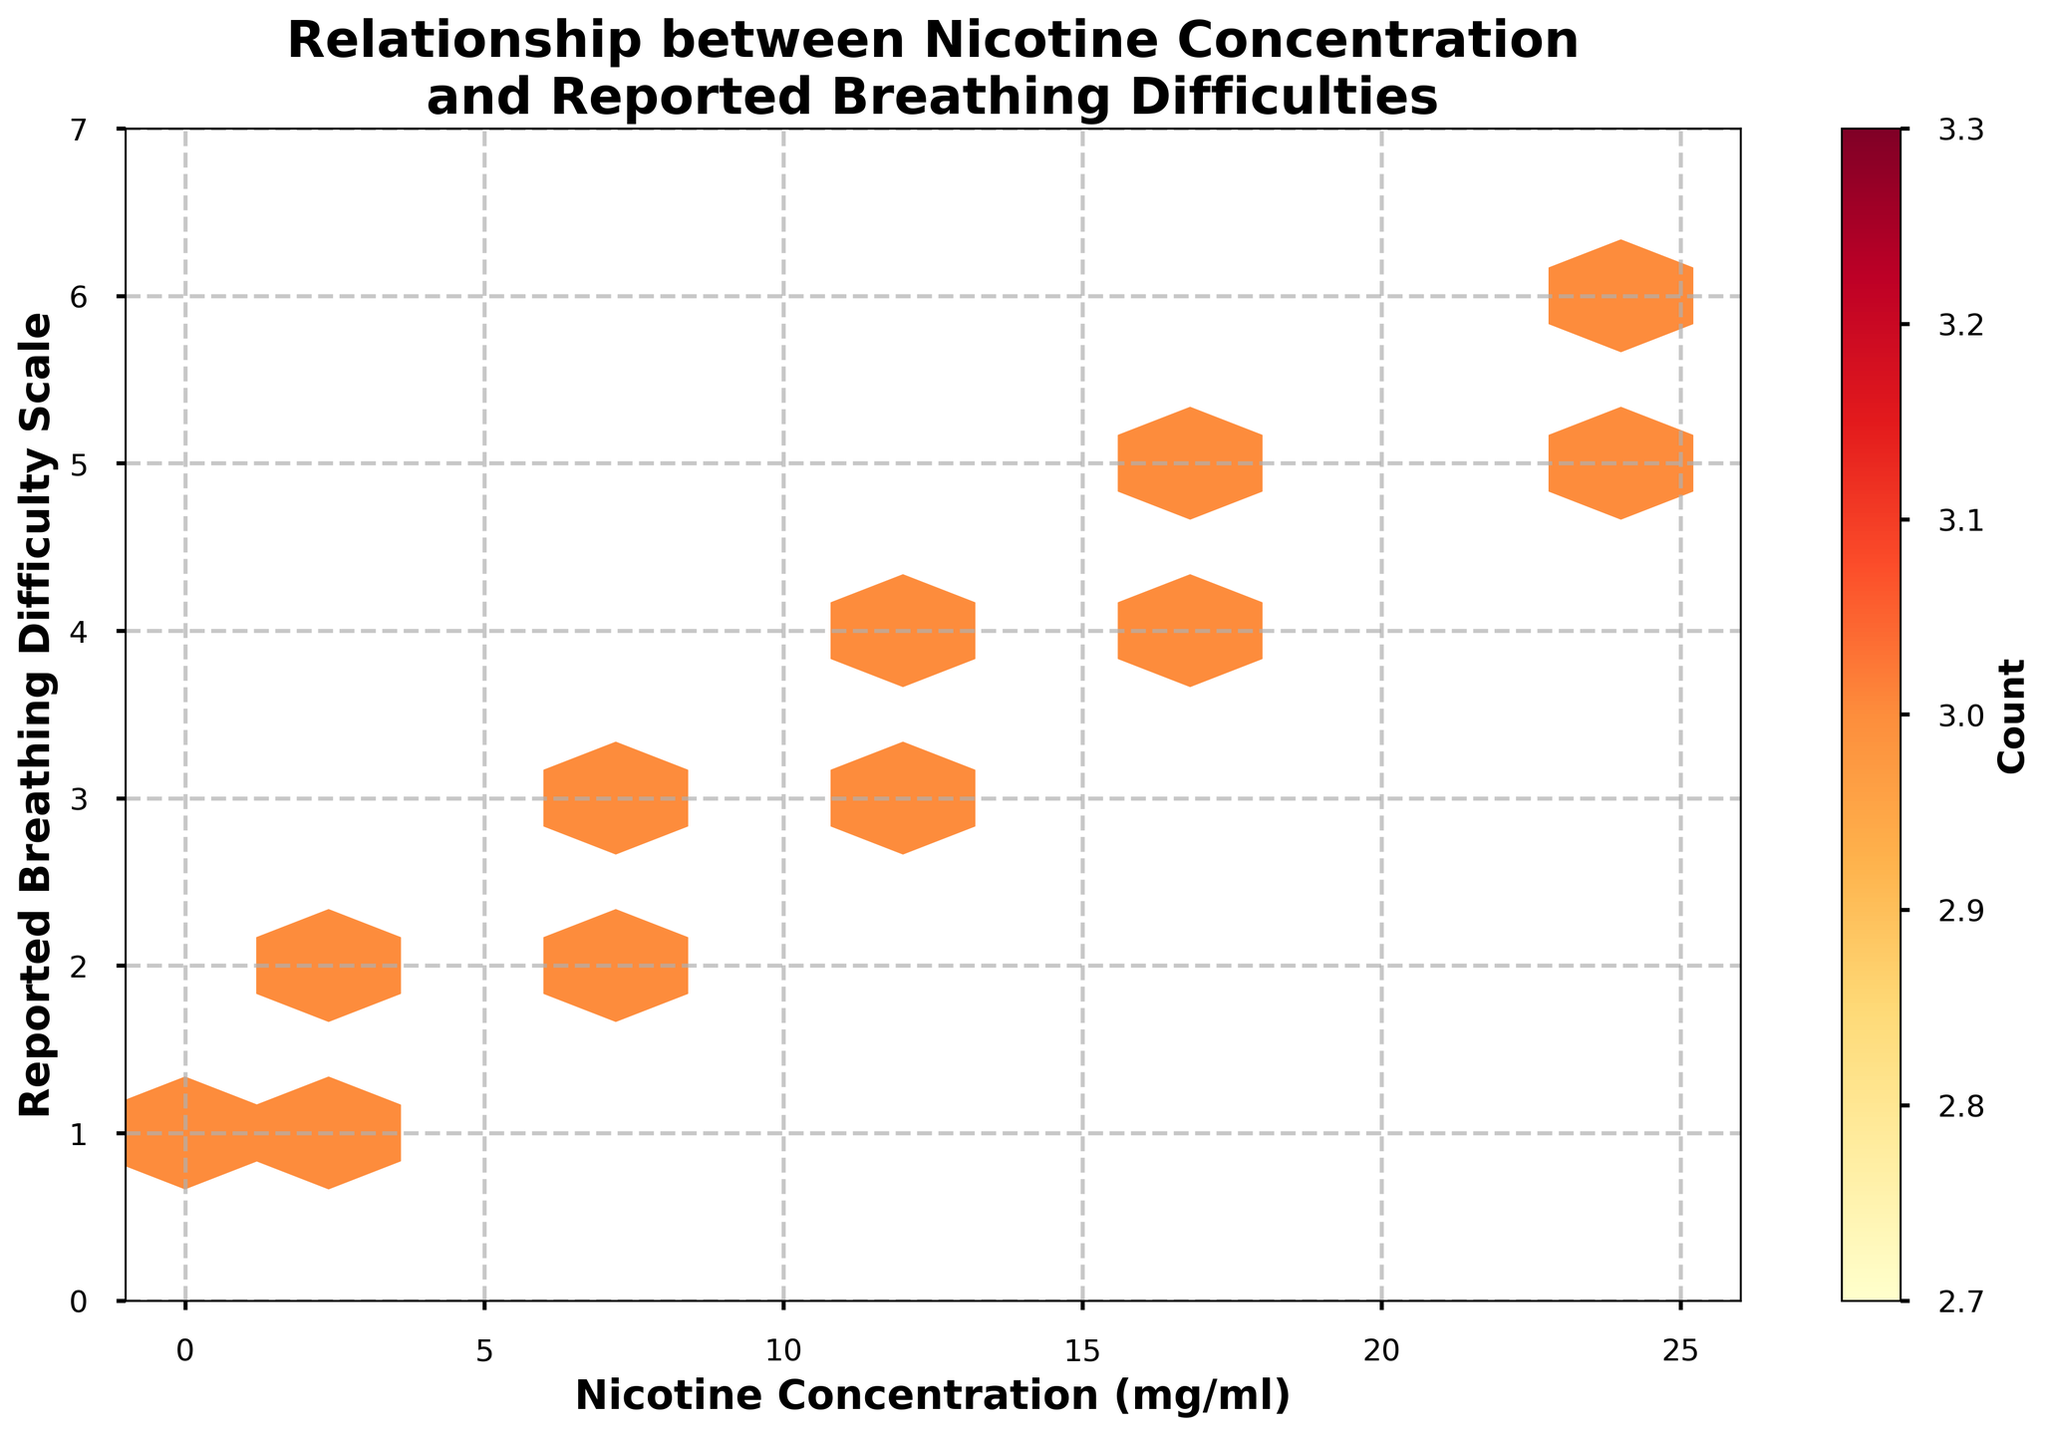What does the title of the plot indicate? The title of the plot is "Relationship between Nicotine Concentration and Reported Breathing Difficulties." It indicates that the plot aims to display the relationship between the nicotine concentration in e-liquids and the reported breathing difficulties among vapers.
Answer: Relationship between Nicotine Concentration and Reported Breathing Difficulties What are the axes labels in the plot? The x-axis is labeled "Nicotine Concentration (mg/ml)" and the y-axis is labeled "Reported Breathing Difficulty Scale."
Answer: Nicotine Concentration (mg/ml) and Reported Breathing Difficulty Scale What is the color of the hexagons that represents the highest density of data points? The color of the hexagons with the highest density of data points is the darkest shade in the colormap 'YlOrRd,' which is deep red.
Answer: Deep red How many different data points are represented on the plot? The plot is based on 24 data points for each unique combination of nicotine concentration and reported breathing difficulty scale. With 5 unique nicotine concentration levels (0, 3, 6, 12, 18, and 24) and 6 unique breathing difficulty scales (1 to 6), all combinations are presented, resulting in 30 points. However, the exact plot shows repeated measures, indicating 24 data points, but each unique combination sums up to 18 differently distributed.
Answer: 18 Which nicotine concentration has the highest reported breathing difficulty scale? By looking at the y-axis and comparing it with the highest hexbin density, nicotine concentration of 24 mg/ml shows the highest reported breathing difficulty scale of 6.
Answer: 24 mg/ml What is the central tendency of reported breathing difficulties for nicotine concentration around 12 mg/ml? Observing the hexagon density clusters around the nicotine concentration of 12 mg/ml, the center of the clusters aligns with a difficulty scale around 3 and 4.
Answer: Around 3 and 4 Is there a clear trend between nicotine concentration and reported breathing difficulties? Yes, there is a clear increasing trend observed in the hexbin plot where higher nicotine concentrations correlate with increased reported breathing difficulties.
Answer: Yes What difference in reported breathing difficulty can be observed between the lowest and highest nicotine concentrations? The lowest nicotine concentration (0 mg/ml) correlates with the lowest breathing difficulty score of 1, while the highest nicotine concentration (24 mg/ml) correlates with the highest breathing difficulty score of 6. The difference is 6 - 1 = 5.
Answer: 5 Are there any nicotine concentrations with similar reported breathing difficulty scales? Yes, nicotine concentrations of 3 mg/ml and 6 mg/ml both show repeated clusters around the breathing difficulty scales of 1, 2, and 3. Additionally, 18 mg/ml and 24 mg/ml show clusters around 4 and 5.
Answer: Yes How does the density of data points impact the interpretation of the relationship in the hexbin plot? Higher density hexagons indicate more data points at those levels of nicotine concentration and reported difficulties, suggesting stronger evidence of the relationship. In lower-density areas, the correlation might be weaker or less represented.
Answer: Impact varies based on hexagon density 